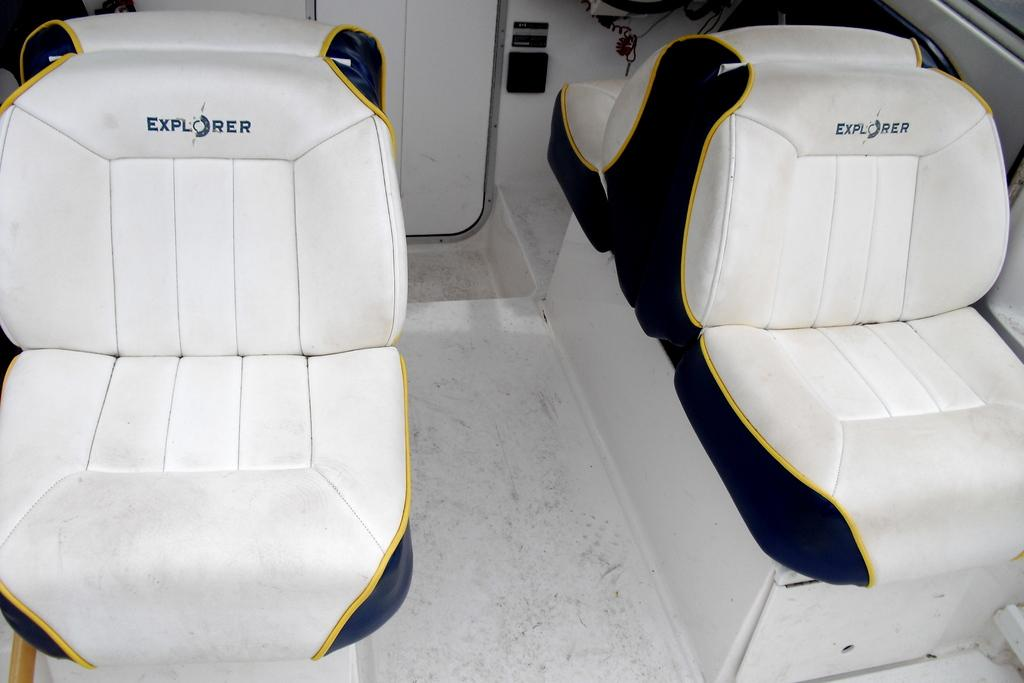How many seats are visible in the image? There are four white color seats in the image. What can be seen on the front of the seats? Something is written on the front of the seats. What is the color of the two objects in the background of the image? The two white color things in the background of the image are also white. How does the seed jump from one seat to another in the image? There is no seed present in the image, and therefore no such activity can be observed. 